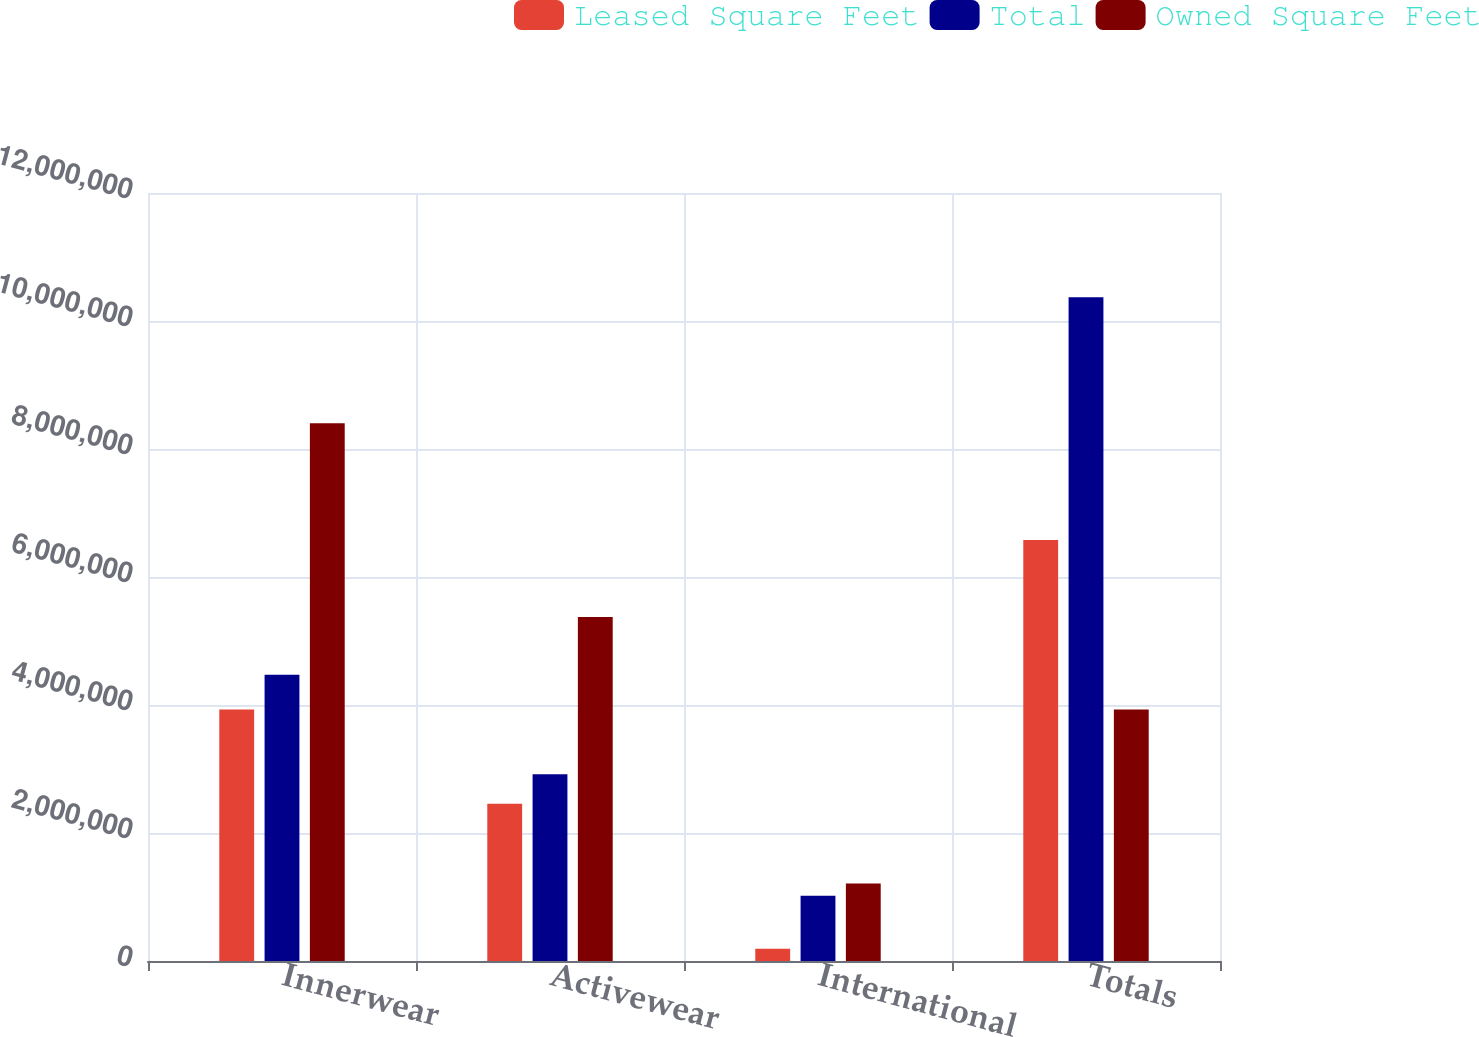Convert chart. <chart><loc_0><loc_0><loc_500><loc_500><stacked_bar_chart><ecel><fcel>Innerwear<fcel>Activewear<fcel>International<fcel>Totals<nl><fcel>Leased Square Feet<fcel>3.92892e+06<fcel>2.45852e+06<fcel>191793<fcel>6.57924e+06<nl><fcel>Total<fcel>4.47457e+06<fcel>2.91739e+06<fcel>1.01764e+06<fcel>1.03721e+07<nl><fcel>Owned Square Feet<fcel>8.4035e+06<fcel>5.37591e+06<fcel>1.20943e+06<fcel>3.92892e+06<nl></chart> 